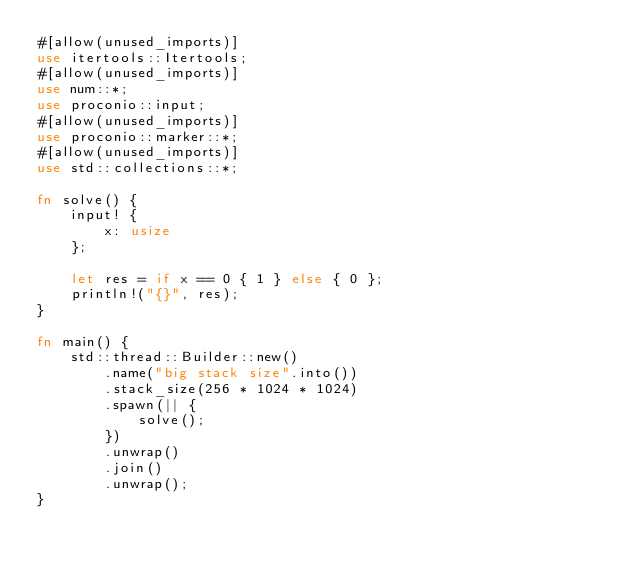Convert code to text. <code><loc_0><loc_0><loc_500><loc_500><_Rust_>#[allow(unused_imports)]
use itertools::Itertools;
#[allow(unused_imports)]
use num::*;
use proconio::input;
#[allow(unused_imports)]
use proconio::marker::*;
#[allow(unused_imports)]
use std::collections::*;

fn solve() {
    input! {
        x: usize
    };

    let res = if x == 0 { 1 } else { 0 };
    println!("{}", res);
}

fn main() {
    std::thread::Builder::new()
        .name("big stack size".into())
        .stack_size(256 * 1024 * 1024)
        .spawn(|| {
            solve();
        })
        .unwrap()
        .join()
        .unwrap();
}
</code> 